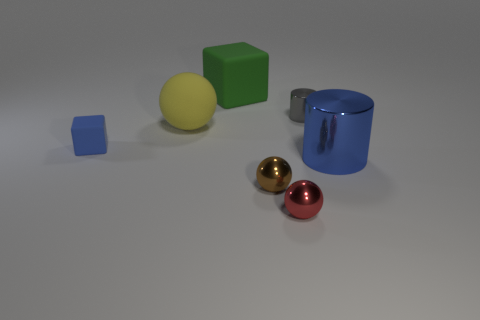Add 1 tiny gray cylinders. How many objects exist? 8 Subtract all balls. How many objects are left? 4 Subtract all small cyan shiny spheres. Subtract all large shiny things. How many objects are left? 6 Add 7 small red metal objects. How many small red metal objects are left? 8 Add 4 big cubes. How many big cubes exist? 5 Subtract 0 purple cylinders. How many objects are left? 7 